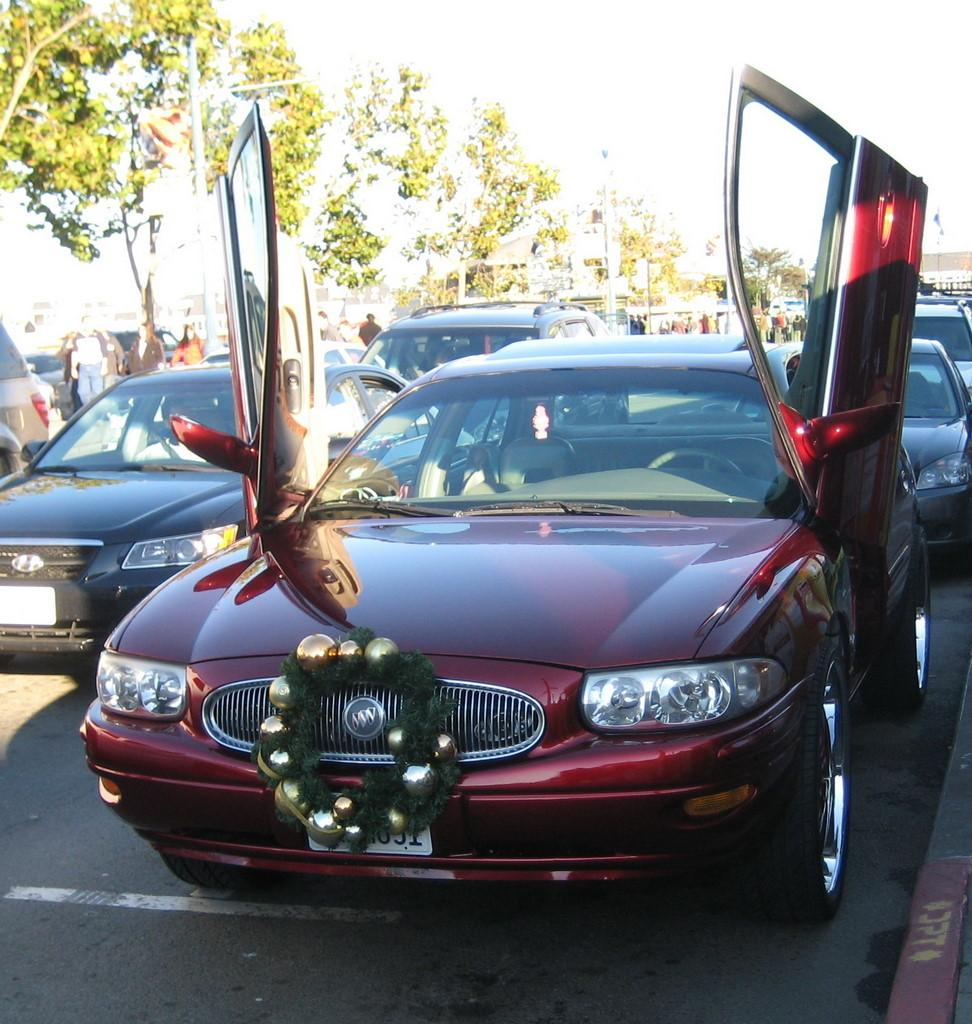What is present on the road in the image? There are vehicles on the road in the image. Can you describe the appearance of the vehicles? The vehicles are in different colors. What can be seen in the background of the image? There are persons and trees in the background, and the sky is visible. How many kittens are playing basketball on the road in the image? There are no kittens or basketballs present in the image; it features vehicles on the road. Can you tell me the color of the match that is being used in the image? There is no match present in the image. 